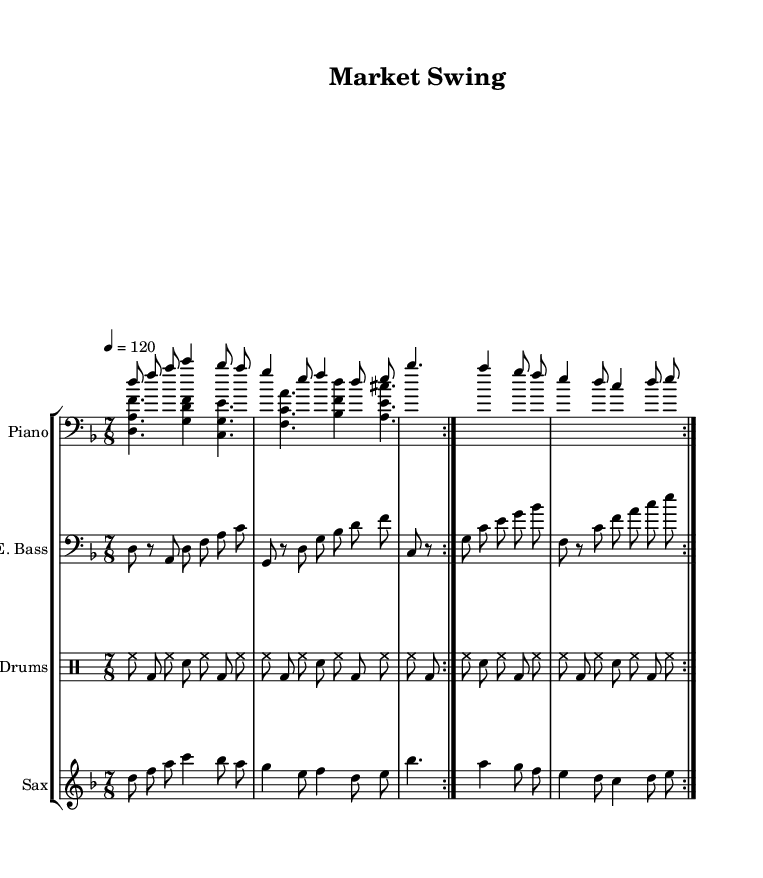What is the key signature of this music? The key signature is indicated at the beginning of the sheet music, with two flats shown on the staff, which corresponds to the key of D minor.
Answer: D minor What is the time signature? The time signature is located at the beginning of the piece, shown as 7/8, indicating that there are seven beats in each measure, and the eighth note gets one beat.
Answer: 7/8 What is the tempo marking? The tempo marking is shown at the beginning, which states "4 = 120," meaning the quarter note should be played at a speed of 120 beats per minute.
Answer: 120 How many times do the piano parts repeat? Both the right-hand and left-hand piano parts show a repeat sign (volta) that indicates they should be played two times in total.
Answer: 2 What is the highest note in the soprano saxophone part? By examining the saxophone part, the highest note is the B flat, which occurs in the second measure of the repeat cycle.
Answer: B flat How does the drum pattern reflect the structure of the music? The drum part follows a consistent pattern of hi-hat, bass drum, and snare drum, which emphasizes the 7/8 time signature by creating a rhythmic pulse that matches the overall swing feel of jazz fusion.
Answer: Consistent pattern 